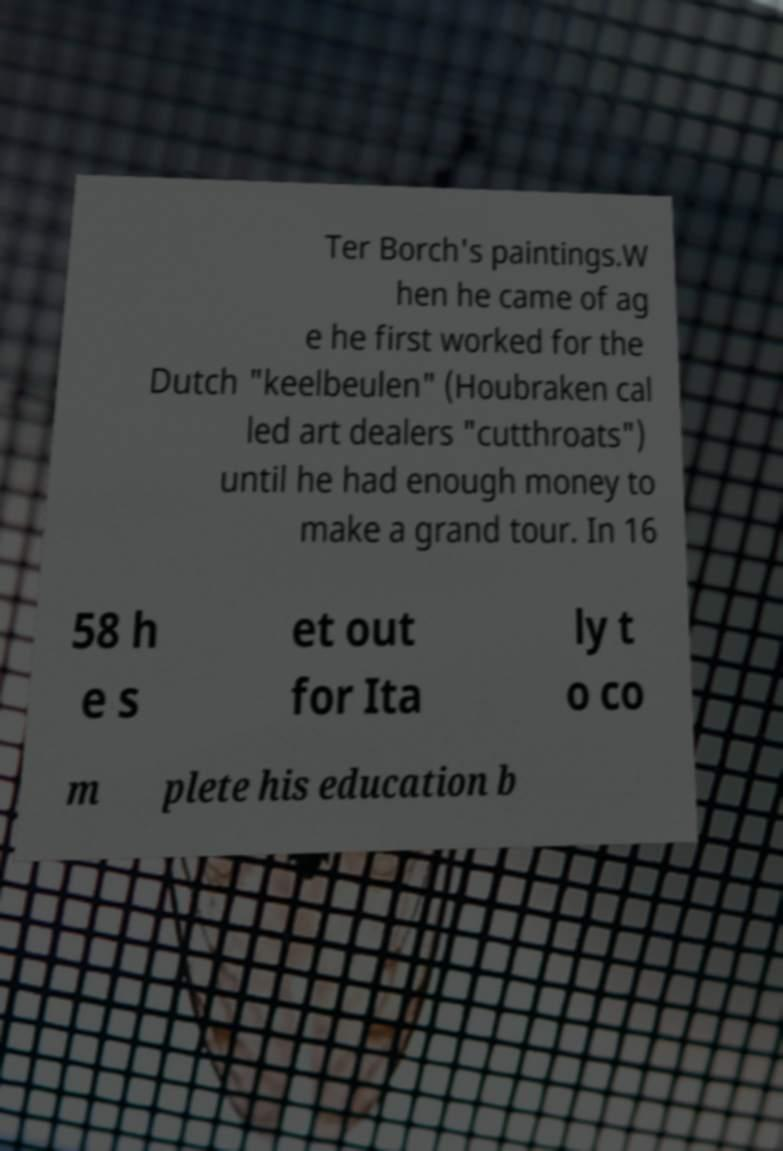Can you read and provide the text displayed in the image?This photo seems to have some interesting text. Can you extract and type it out for me? Ter Borch's paintings.W hen he came of ag e he first worked for the Dutch "keelbeulen" (Houbraken cal led art dealers "cutthroats") until he had enough money to make a grand tour. In 16 58 h e s et out for Ita ly t o co m plete his education b 